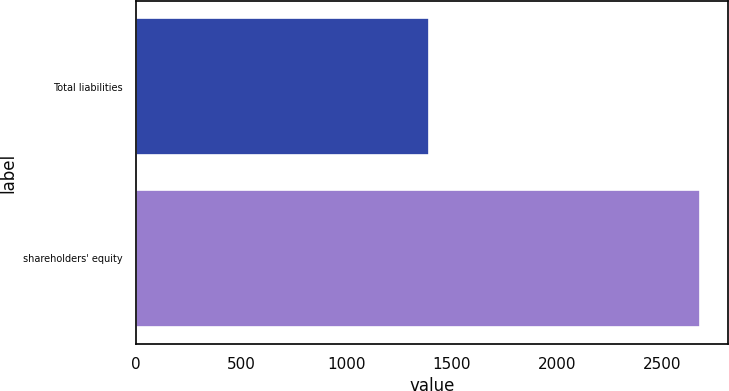<chart> <loc_0><loc_0><loc_500><loc_500><bar_chart><fcel>Total liabilities<fcel>shareholders' equity<nl><fcel>1392.6<fcel>2677.7<nl></chart> 